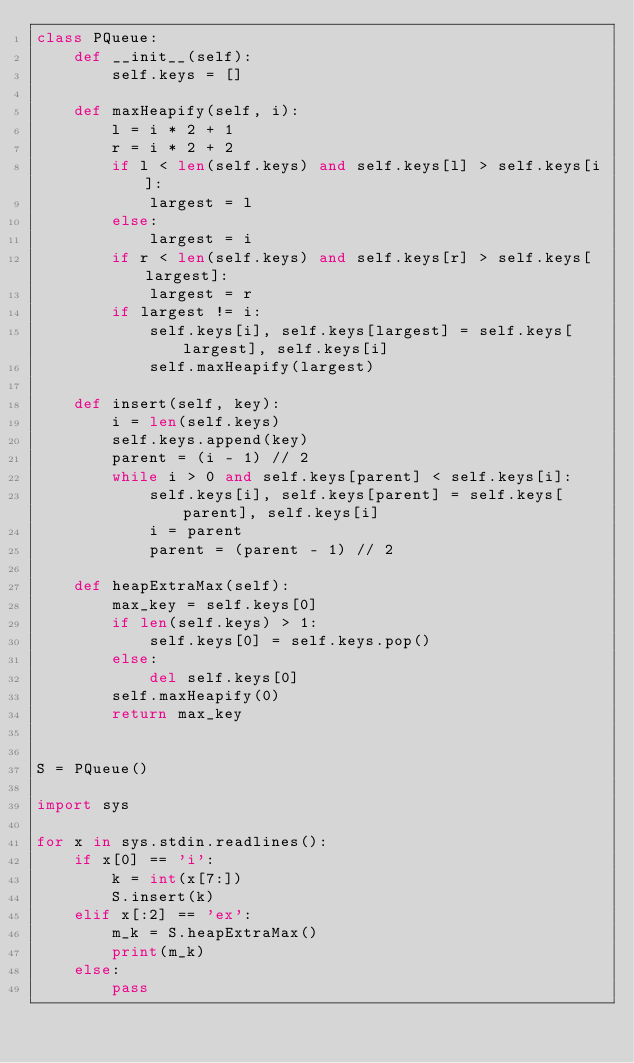Convert code to text. <code><loc_0><loc_0><loc_500><loc_500><_Python_>class PQueue:
    def __init__(self):
        self.keys = []
        
    def maxHeapify(self, i):
        l = i * 2 + 1
        r = i * 2 + 2
        if l < len(self.keys) and self.keys[l] > self.keys[i]:
            largest = l
        else:
            largest = i
        if r < len(self.keys) and self.keys[r] > self.keys[largest]:
            largest = r
        if largest != i:
            self.keys[i], self.keys[largest] = self.keys[largest], self.keys[i]
            self.maxHeapify(largest)

    def insert(self, key):
        i = len(self.keys)
        self.keys.append(key)
        parent = (i - 1) // 2
        while i > 0 and self.keys[parent] < self.keys[i]:
            self.keys[i], self.keys[parent] = self.keys[parent], self.keys[i]
            i = parent
            parent = (parent - 1) // 2

    def heapExtraMax(self):
        max_key = self.keys[0]
        if len(self.keys) > 1:
            self.keys[0] = self.keys.pop()
        else:
            del self.keys[0]
        self.maxHeapify(0)
        return max_key


S = PQueue()

import sys

for x in sys.stdin.readlines():
    if x[0] == 'i':
        k = int(x[7:])
        S.insert(k)
    elif x[:2] == 'ex':
        m_k = S.heapExtraMax()
        print(m_k)
    else:
        pass</code> 